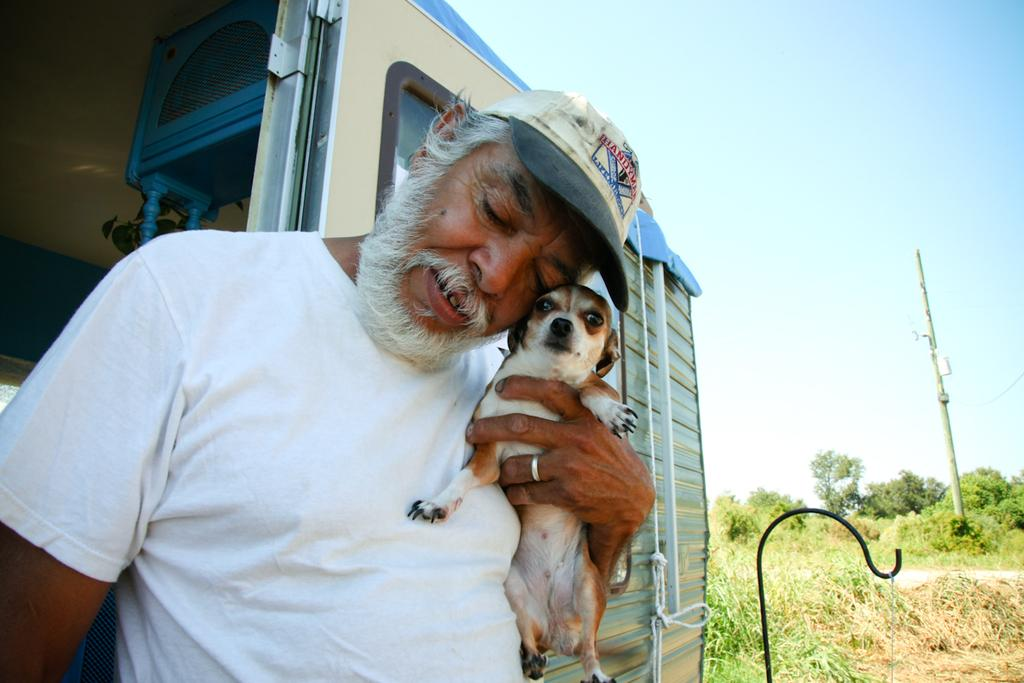Who is present in the image? There is a man in the image. What is the man holding in the image? The man is holding a dog. What can be seen in the background of the image? There are trees visible in the background of the image. What type of destruction can be seen in the image? There is no destruction present in the image; it features a man holding a dog with trees in the background. 